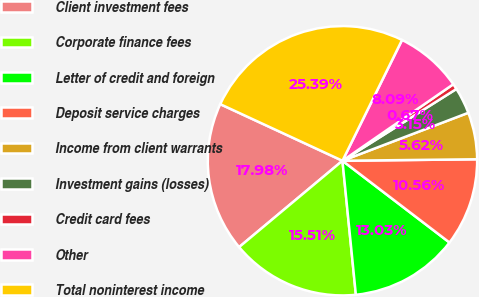Convert chart to OTSL. <chart><loc_0><loc_0><loc_500><loc_500><pie_chart><fcel>Client investment fees<fcel>Corporate finance fees<fcel>Letter of credit and foreign<fcel>Deposit service charges<fcel>Income from client warrants<fcel>Investment gains (losses)<fcel>Credit card fees<fcel>Other<fcel>Total noninterest income<nl><fcel>17.98%<fcel>15.51%<fcel>13.03%<fcel>10.56%<fcel>5.62%<fcel>3.15%<fcel>0.67%<fcel>8.09%<fcel>25.39%<nl></chart> 